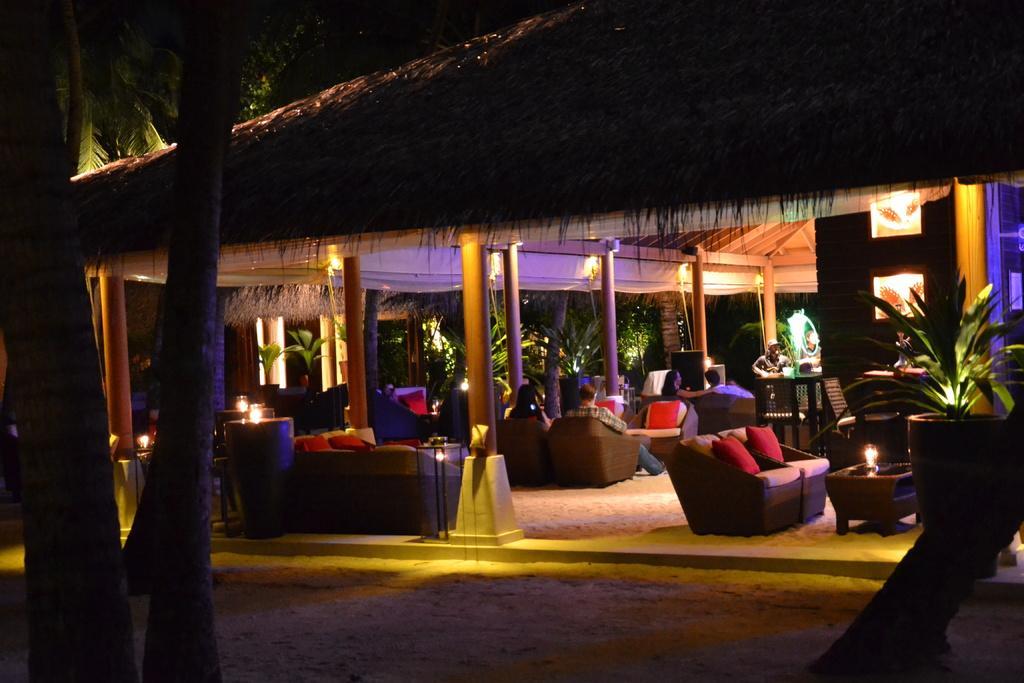How would you summarize this image in a sentence or two? In this image I can see chairs and pillow. There is a table on the table there is alight. In front few people are sitting on the chair. There are under the hut. On the right side there is a flower pot there are trees. 